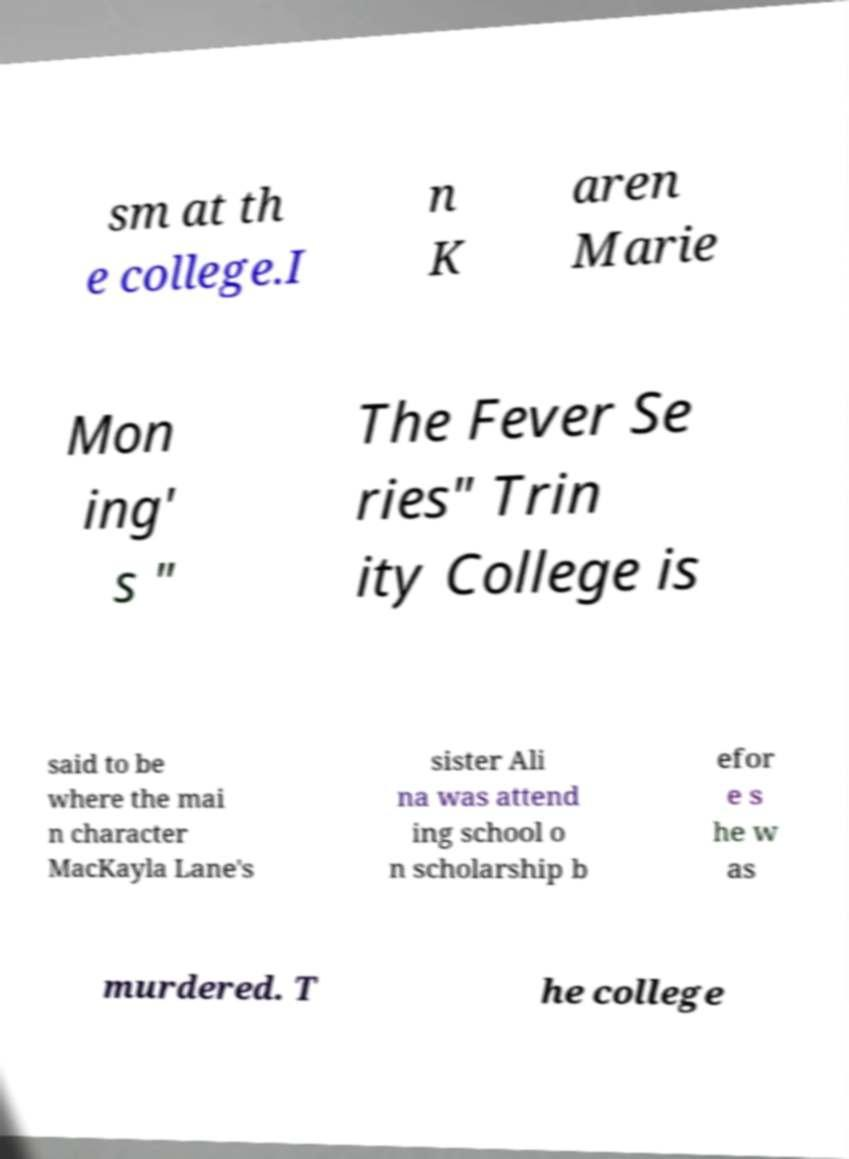Please read and relay the text visible in this image. What does it say? sm at th e college.I n K aren Marie Mon ing' s " The Fever Se ries" Trin ity College is said to be where the mai n character MacKayla Lane's sister Ali na was attend ing school o n scholarship b efor e s he w as murdered. T he college 